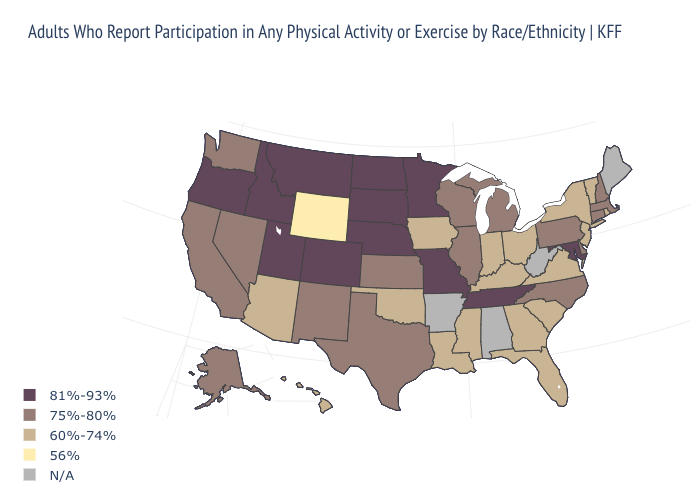Which states hav the highest value in the West?
Concise answer only. Colorado, Idaho, Montana, Oregon, Utah. Does the first symbol in the legend represent the smallest category?
Give a very brief answer. No. Does the map have missing data?
Answer briefly. Yes. Among the states that border Idaho , does Wyoming have the lowest value?
Short answer required. Yes. What is the value of South Carolina?
Be succinct. 60%-74%. Does Nevada have the highest value in the West?
Give a very brief answer. No. Is the legend a continuous bar?
Quick response, please. No. What is the value of Nebraska?
Give a very brief answer. 81%-93%. What is the value of Michigan?
Short answer required. 75%-80%. Name the states that have a value in the range 75%-80%?
Short answer required. Alaska, California, Connecticut, Delaware, Illinois, Kansas, Massachusetts, Michigan, Nevada, New Hampshire, New Mexico, North Carolina, Pennsylvania, Texas, Washington, Wisconsin. How many symbols are there in the legend?
Answer briefly. 5. Name the states that have a value in the range 60%-74%?
Short answer required. Arizona, Florida, Georgia, Hawaii, Indiana, Iowa, Kentucky, Louisiana, Mississippi, New Jersey, New York, Ohio, Oklahoma, Rhode Island, South Carolina, Vermont, Virginia. Does Hawaii have the highest value in the West?
Quick response, please. No. Which states have the lowest value in the West?
Write a very short answer. Wyoming. 